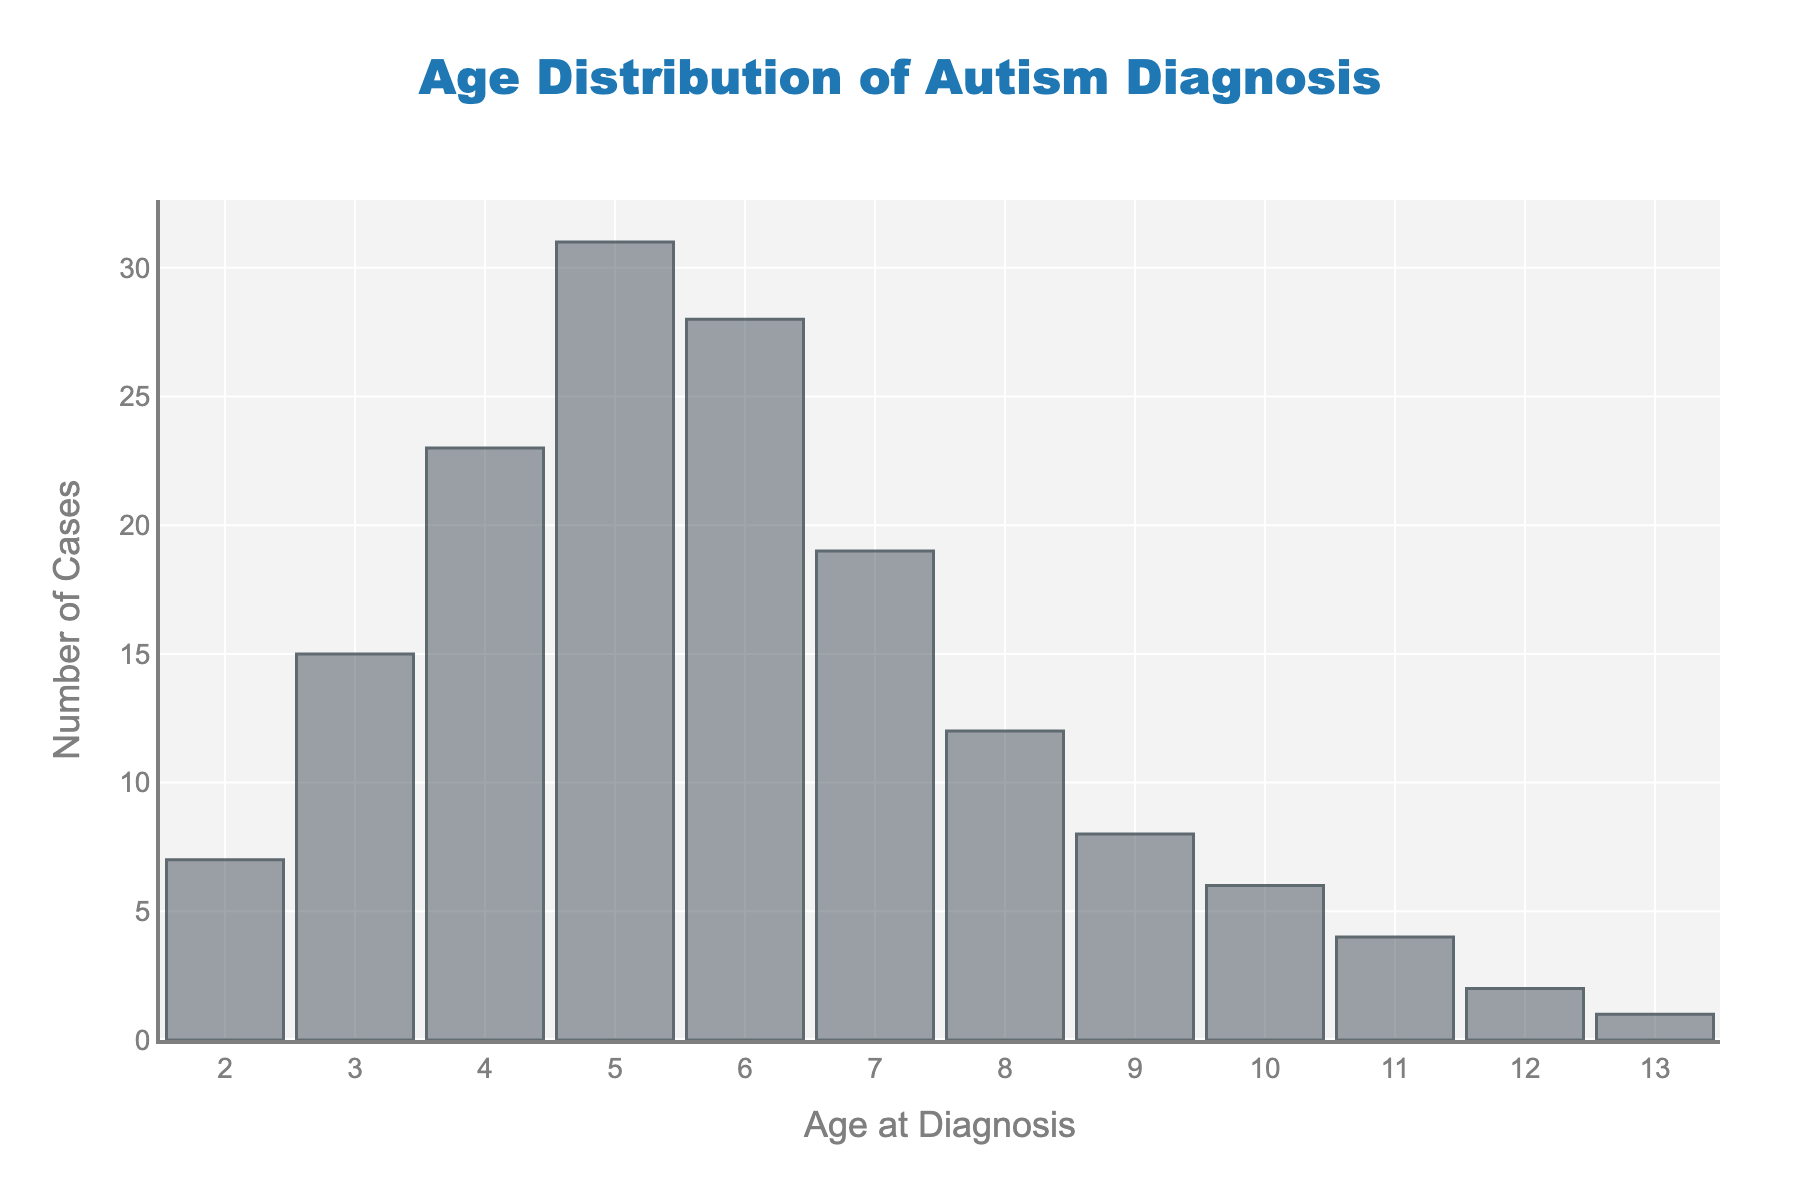What is the title of the histogram? The title is usually located at the top of the figure and is meant to provide an overview of what the data represents, in this case, "Age Distribution of Autism Diagnosis".
Answer: Age Distribution of Autism Diagnosis What is the most frequently occurring age at diagnosis in the study cohort? To identify the most frequently occurring age at diagnosis, look for the bar with the highest frequency. The tallest bar on the histogram corresponds to age 5.
Answer: 5 years old Which age group has the least number of autism diagnoses? To determine the age group with the least number of autism diagnoses, look for the shortest bar in the histogram, which corresponds to age 13.
Answer: 13 years old How many total diagnoses are recorded for ages under 5? To find the total diagnoses under age 5, sum the frequencies for ages 2, 3, and 4. These frequencies are 7, 15, and 23 respectively. Therefore, 7 + 15 + 23 = 45.
Answer: 45 cases Is age 10 more common or less common than age 8 for autism diagnosis based on the histogram? To compare the number of diagnoses at ages 10 and 8, look at the corresponding bars. Age 10 has a frequency of 6, while age 8 has a frequency of 12. Thus, age 10 is less common.
Answer: Less common What is the overall trend in the number of diagnoses as age increases from 2 to 7? To determine the trend, observe the pattern of the bar heights from ages 2 to 7. The frequencies generally increase until age 5 and then start decreasing.
Answer: Increasing, then decreasing What is the combined frequency of autism diagnoses for ages 9 and above? Sum the frequencies for ages 9, 10, 11, 12, and 13. The frequencies are 8, 6, 4, 2, and 1 respectively. Therefore, 8 + 6 + 4 + 2 + 1 = 21.
Answer: 21 cases Which age group represents the median number of diagnoses, and what is that number? To find the median, identify the middle value when the data is ordered. With 11 age groups, the median age is the 6th one when sorted. The 6th age group is 5 years old with a frequency of 31.
Answer: 5 years old, 31 cases How does the number of diagnoses at age 6 compare to age 4? Refer to the heights of the bars for ages 6 and 4. Age 6 has 28 cases, while age 4 has 23 cases. Age 6 has more diagnoses than age 4.
Answer: Age 6 has more diagnoses What is the frequency difference between the highest and lowest diagnoses? First, identify the highest frequency (31 at age 5) and the lowest frequency (1 at age 13). The difference is 31 - 1 = 30.
Answer: 30 